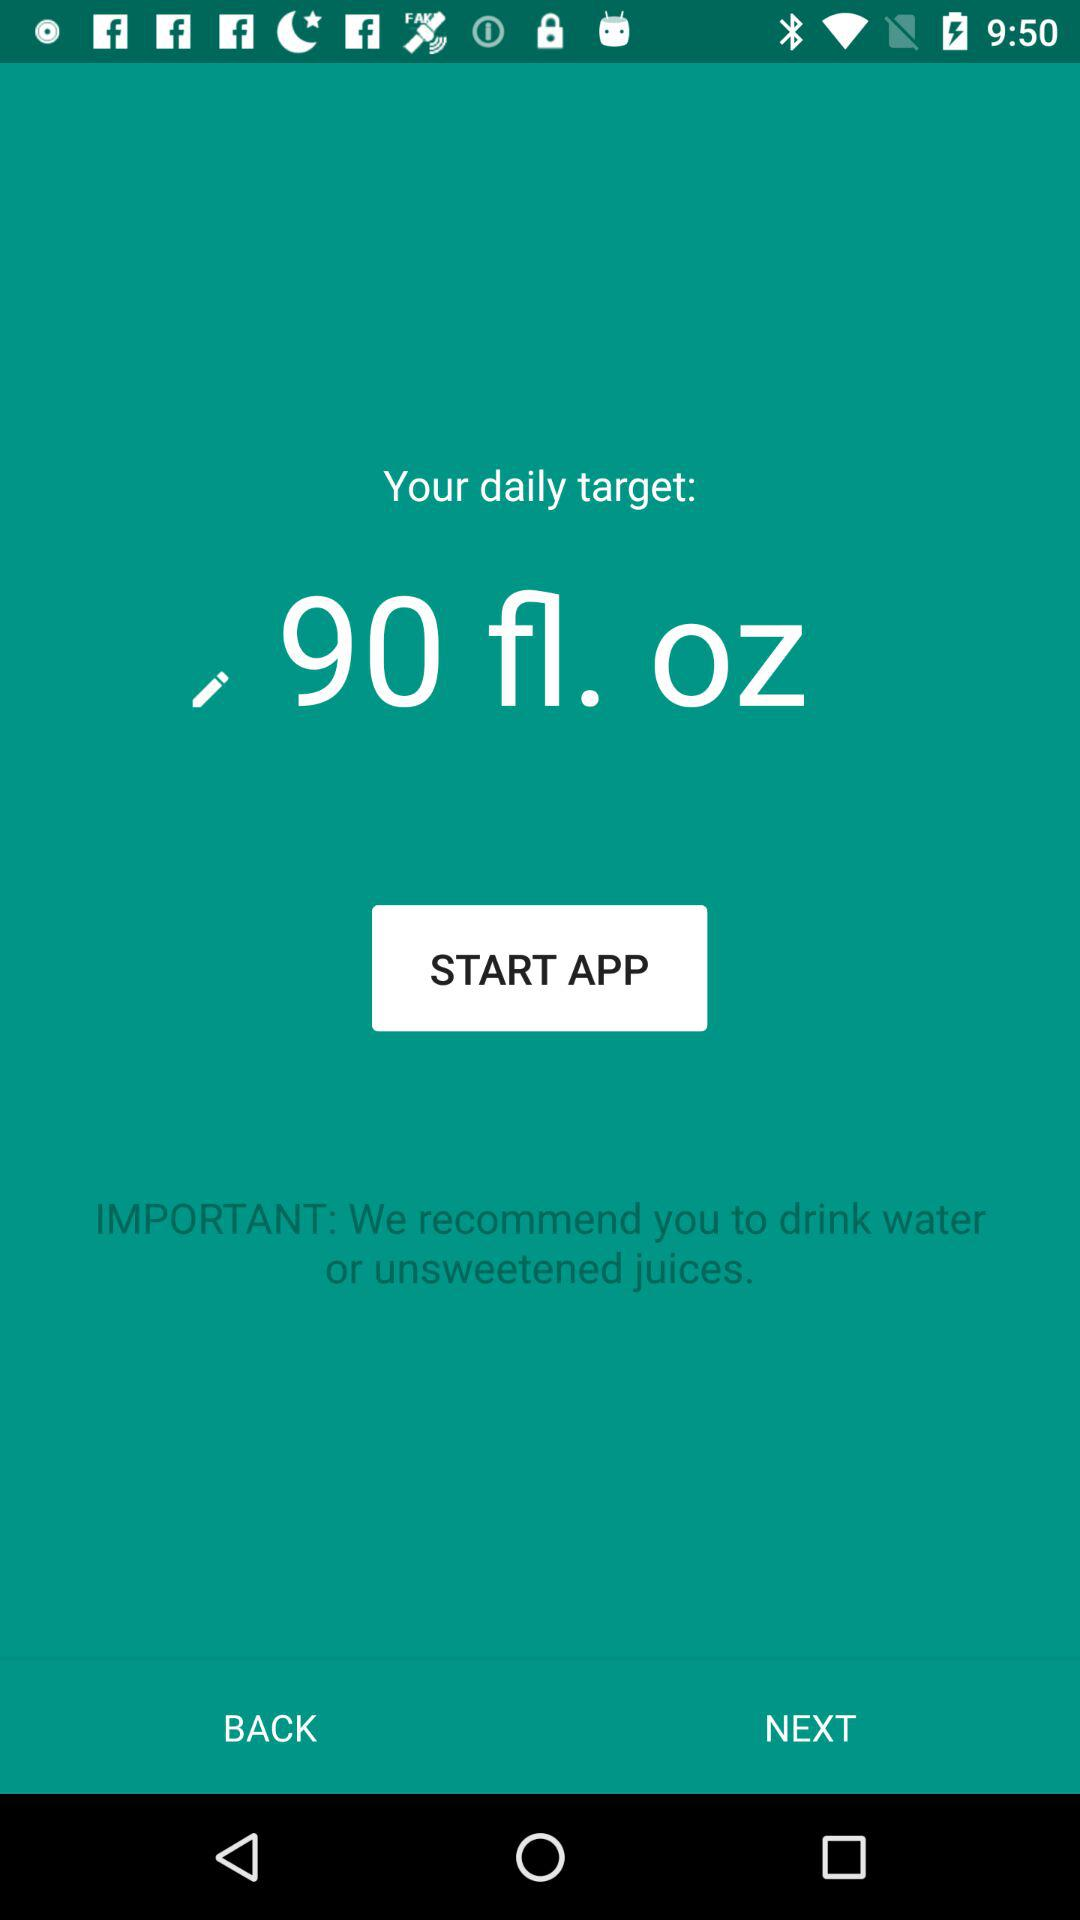How old is the user?
When the provided information is insufficient, respond with <no answer>. <no answer> 